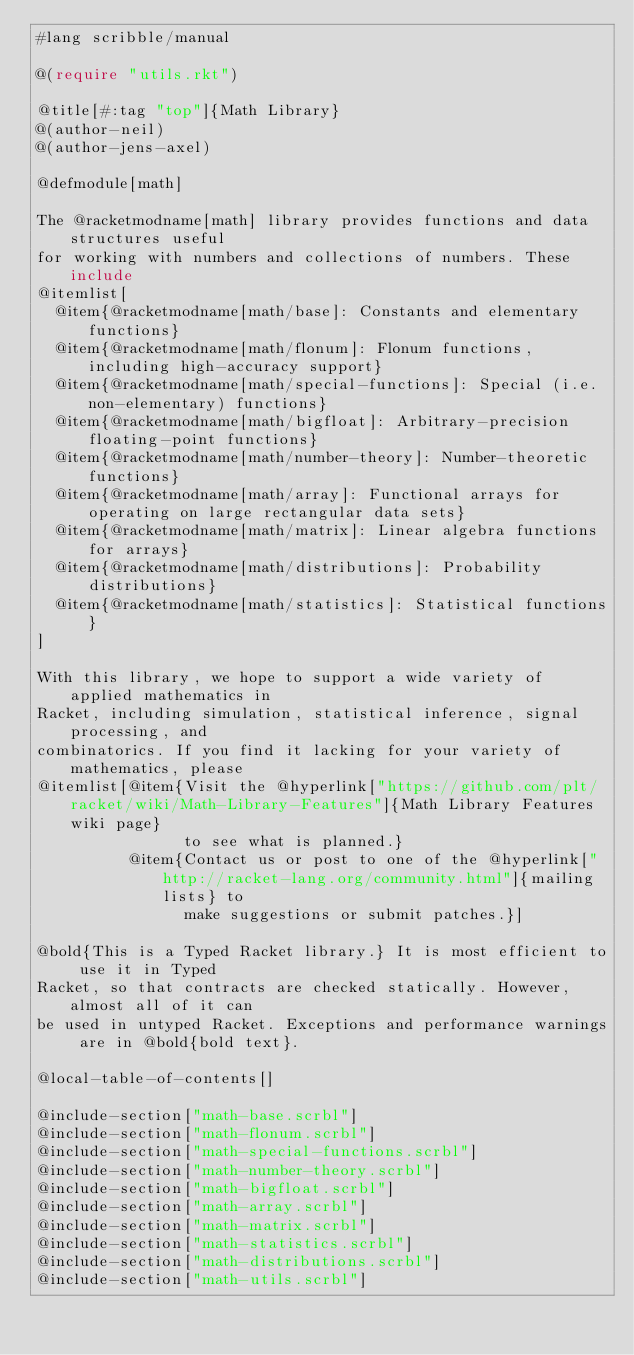Convert code to text. <code><loc_0><loc_0><loc_500><loc_500><_Racket_>#lang scribble/manual

@(require "utils.rkt")

@title[#:tag "top"]{Math Library}
@(author-neil)
@(author-jens-axel)

@defmodule[math]

The @racketmodname[math] library provides functions and data structures useful
for working with numbers and collections of numbers. These include
@itemlist[
  @item{@racketmodname[math/base]: Constants and elementary functions}
  @item{@racketmodname[math/flonum]: Flonum functions, including high-accuracy support}
  @item{@racketmodname[math/special-functions]: Special (i.e. non-elementary) functions}
  @item{@racketmodname[math/bigfloat]: Arbitrary-precision floating-point functions}
  @item{@racketmodname[math/number-theory]: Number-theoretic functions}
  @item{@racketmodname[math/array]: Functional arrays for operating on large rectangular data sets}
  @item{@racketmodname[math/matrix]: Linear algebra functions for arrays}
  @item{@racketmodname[math/distributions]: Probability distributions}
  @item{@racketmodname[math/statistics]: Statistical functions}
]

With this library, we hope to support a wide variety of applied mathematics in
Racket, including simulation, statistical inference, signal processing, and
combinatorics. If you find it lacking for your variety of mathematics, please
@itemlist[@item{Visit the @hyperlink["https://github.com/plt/racket/wiki/Math-Library-Features"]{Math Library Features wiki page}
                to see what is planned.}
          @item{Contact us or post to one of the @hyperlink["http://racket-lang.org/community.html"]{mailing lists} to
                make suggestions or submit patches.}]

@bold{This is a Typed Racket library.} It is most efficient to use it in Typed
Racket, so that contracts are checked statically. However, almost all of it can
be used in untyped Racket. Exceptions and performance warnings are in @bold{bold text}.

@local-table-of-contents[]

@include-section["math-base.scrbl"]
@include-section["math-flonum.scrbl"]
@include-section["math-special-functions.scrbl"]
@include-section["math-number-theory.scrbl"]
@include-section["math-bigfloat.scrbl"]
@include-section["math-array.scrbl"]
@include-section["math-matrix.scrbl"]
@include-section["math-statistics.scrbl"]
@include-section["math-distributions.scrbl"]
@include-section["math-utils.scrbl"]
</code> 